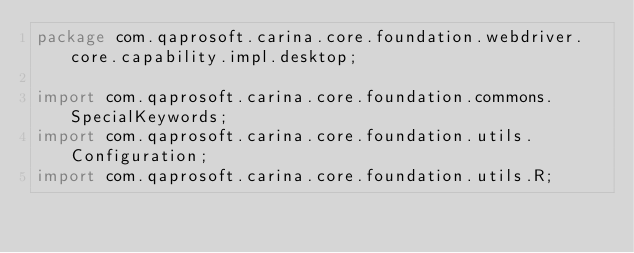Convert code to text. <code><loc_0><loc_0><loc_500><loc_500><_Java_>package com.qaprosoft.carina.core.foundation.webdriver.core.capability.impl.desktop;

import com.qaprosoft.carina.core.foundation.commons.SpecialKeywords;
import com.qaprosoft.carina.core.foundation.utils.Configuration;
import com.qaprosoft.carina.core.foundation.utils.R;</code> 